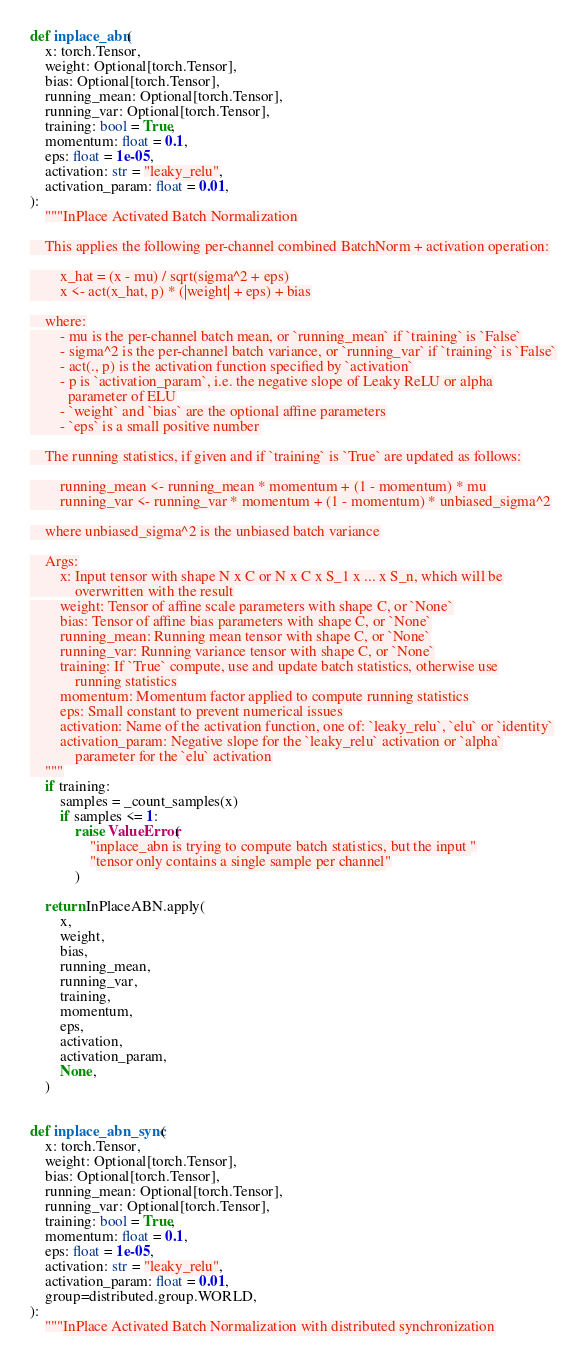<code> <loc_0><loc_0><loc_500><loc_500><_Python_>def inplace_abn(
    x: torch.Tensor,
    weight: Optional[torch.Tensor],
    bias: Optional[torch.Tensor],
    running_mean: Optional[torch.Tensor],
    running_var: Optional[torch.Tensor],
    training: bool = True,
    momentum: float = 0.1,
    eps: float = 1e-05,
    activation: str = "leaky_relu",
    activation_param: float = 0.01,
):
    """InPlace Activated Batch Normalization

    This applies the following per-channel combined BatchNorm + activation operation:

        x_hat = (x - mu) / sqrt(sigma^2 + eps)
        x <- act(x_hat, p) * (|weight| + eps) + bias

    where:
        - mu is the per-channel batch mean, or `running_mean` if `training` is `False`
        - sigma^2 is the per-channel batch variance, or `running_var` if `training` is `False`
        - act(., p) is the activation function specified by `activation`
        - p is `activation_param`, i.e. the negative slope of Leaky ReLU or alpha
          parameter of ELU
        - `weight` and `bias` are the optional affine parameters
        - `eps` is a small positive number

    The running statistics, if given and if `training` is `True` are updated as follows:

        running_mean <- running_mean * momentum + (1 - momentum) * mu
        running_var <- running_var * momentum + (1 - momentum) * unbiased_sigma^2

    where unbiased_sigma^2 is the unbiased batch variance

    Args:
        x: Input tensor with shape N x C or N x C x S_1 x ... x S_n, which will be
            overwritten with the result
        weight: Tensor of affine scale parameters with shape C, or `None`
        bias: Tensor of affine bias parameters with shape C, or `None`
        running_mean: Running mean tensor with shape C, or `None`
        running_var: Running variance tensor with shape C, or `None`
        training: If `True` compute, use and update batch statistics, otherwise use
            running statistics
        momentum: Momentum factor applied to compute running statistics
        eps: Small constant to prevent numerical issues
        activation: Name of the activation function, one of: `leaky_relu`, `elu` or `identity`
        activation_param: Negative slope for the `leaky_relu` activation or `alpha`
            parameter for the `elu` activation
    """
    if training:
        samples = _count_samples(x)
        if samples <= 1:
            raise ValueError(
                "inplace_abn is trying to compute batch statistics, but the input "
                "tensor only contains a single sample per channel"
            )

    return InPlaceABN.apply(
        x,
        weight,
        bias,
        running_mean,
        running_var,
        training,
        momentum,
        eps,
        activation,
        activation_param,
        None,
    )


def inplace_abn_sync(
    x: torch.Tensor,
    weight: Optional[torch.Tensor],
    bias: Optional[torch.Tensor],
    running_mean: Optional[torch.Tensor],
    running_var: Optional[torch.Tensor],
    training: bool = True,
    momentum: float = 0.1,
    eps: float = 1e-05,
    activation: str = "leaky_relu",
    activation_param: float = 0.01,
    group=distributed.group.WORLD,
):
    """InPlace Activated Batch Normalization with distributed synchronization
</code> 